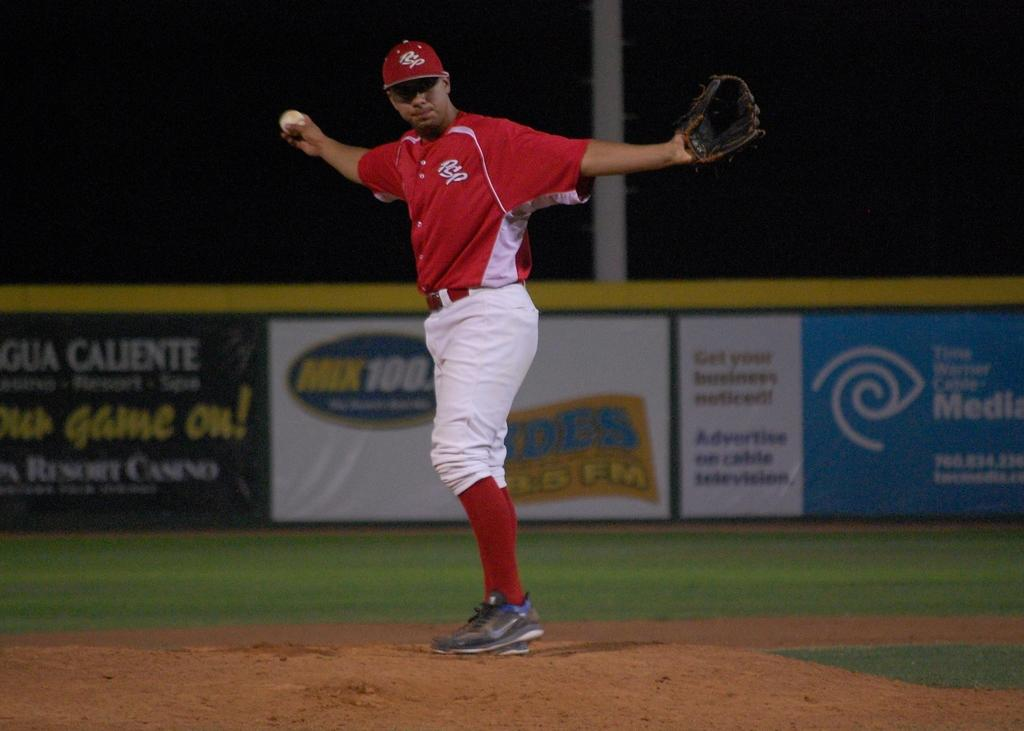<image>
Describe the image concisely. The PSP pitcher is standing on the mound with his arms stretched out. 